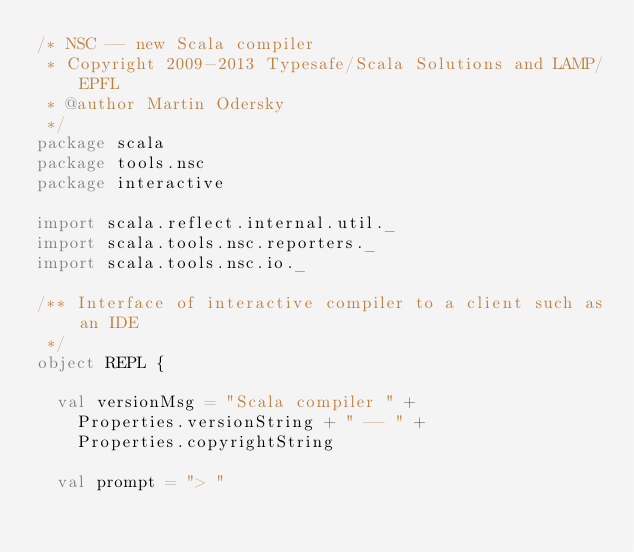<code> <loc_0><loc_0><loc_500><loc_500><_Scala_>/* NSC -- new Scala compiler
 * Copyright 2009-2013 Typesafe/Scala Solutions and LAMP/EPFL
 * @author Martin Odersky
 */
package scala
package tools.nsc
package interactive

import scala.reflect.internal.util._
import scala.tools.nsc.reporters._
import scala.tools.nsc.io._

/** Interface of interactive compiler to a client such as an IDE
 */
object REPL {

  val versionMsg = "Scala compiler " +
    Properties.versionString + " -- " +
    Properties.copyrightString

  val prompt = "> "
</code> 